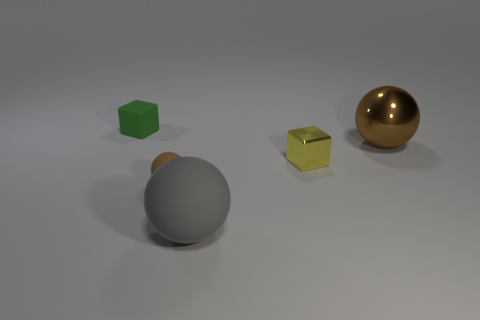Subtract all brown metal spheres. How many spheres are left? 2 Add 4 yellow metallic things. How many objects exist? 9 Subtract all yellow cubes. How many cubes are left? 1 Subtract all balls. How many objects are left? 2 Subtract 1 cubes. How many cubes are left? 1 Subtract 0 gray cylinders. How many objects are left? 5 Subtract all purple balls. Subtract all red blocks. How many balls are left? 3 Subtract all brown cubes. How many red spheres are left? 0 Subtract all small gray blocks. Subtract all green cubes. How many objects are left? 4 Add 5 brown metallic things. How many brown metallic things are left? 6 